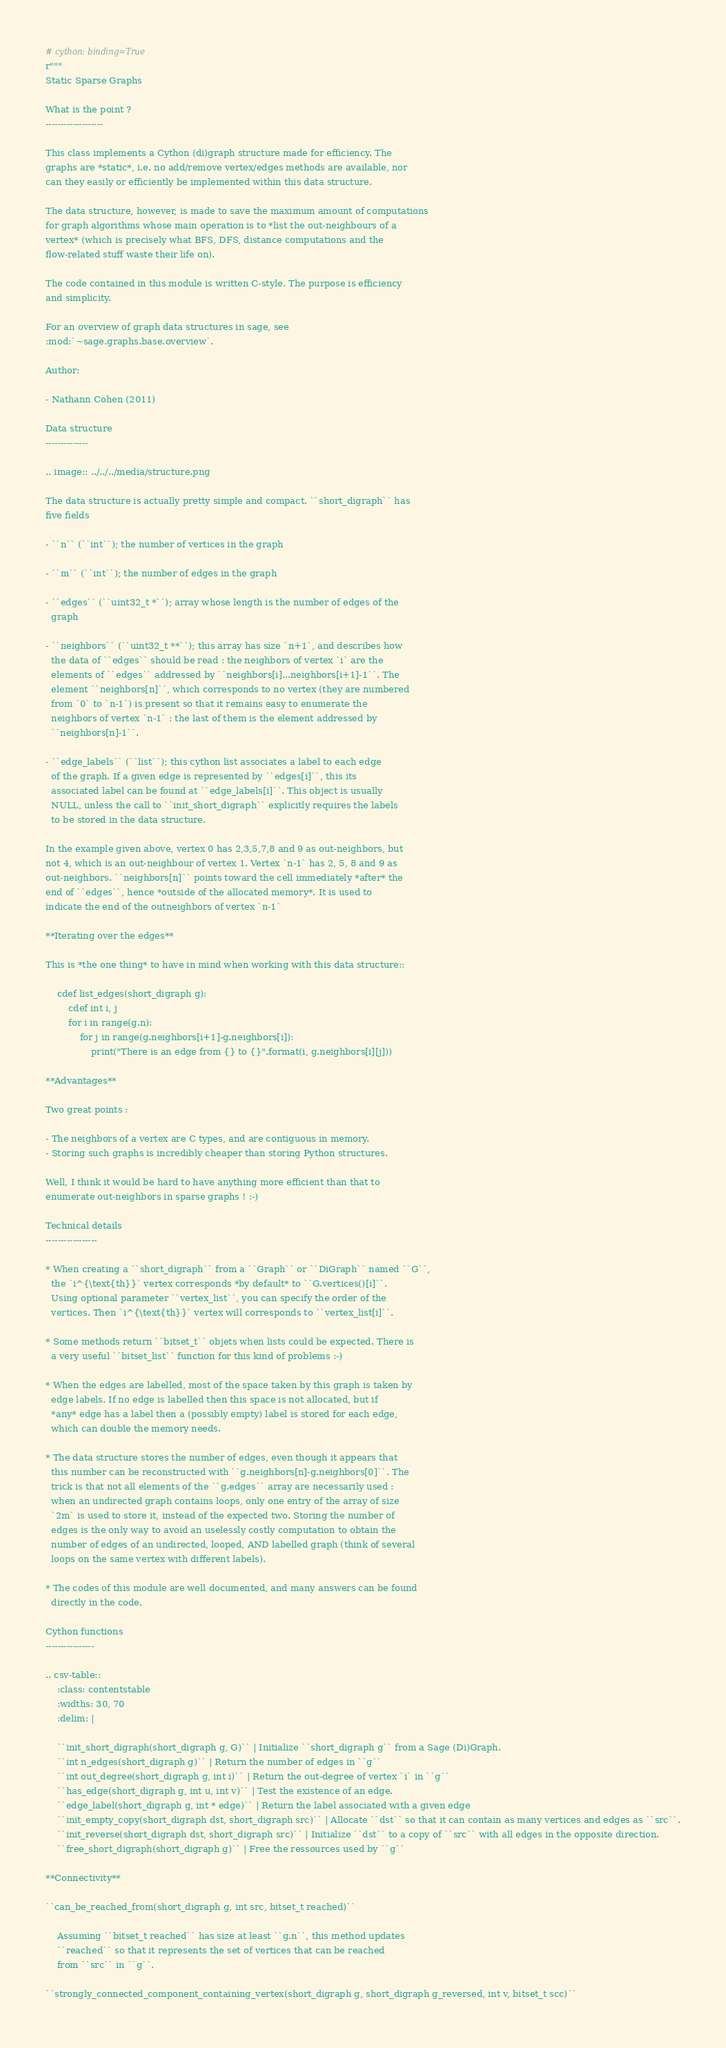Convert code to text. <code><loc_0><loc_0><loc_500><loc_500><_Cython_># cython: binding=True
r"""
Static Sparse Graphs

What is the point ?
-------------------

This class implements a Cython (di)graph structure made for efficiency. The
graphs are *static*, i.e. no add/remove vertex/edges methods are available, nor
can they easily or efficiently be implemented within this data structure.

The data structure, however, is made to save the maximum amount of computations
for graph algorithms whose main operation is to *list the out-neighbours of a
vertex* (which is precisely what BFS, DFS, distance computations and the
flow-related stuff waste their life on).

The code contained in this module is written C-style. The purpose is efficiency
and simplicity.

For an overview of graph data structures in sage, see
:mod:`~sage.graphs.base.overview`.

Author:

- Nathann Cohen (2011)

Data structure
--------------

.. image:: ../../../media/structure.png

The data structure is actually pretty simple and compact. ``short_digraph`` has
five fields

- ``n`` (``int``); the number of vertices in the graph

- ``m`` (``int``); the number of edges in the graph

- ``edges`` (``uint32_t *``); array whose length is the number of edges of the
  graph

- ``neighbors`` (``uint32_t **``); this array has size `n+1`, and describes how
  the data of ``edges`` should be read : the neighbors of vertex `i` are the
  elements of ``edges`` addressed by ``neighbors[i]...neighbors[i+1]-1``. The
  element ``neighbors[n]``, which corresponds to no vertex (they are numbered
  from `0` to `n-1`) is present so that it remains easy to enumerate the
  neighbors of vertex `n-1` : the last of them is the element addressed by
  ``neighbors[n]-1``.

- ``edge_labels`` (``list``); this cython list associates a label to each edge
  of the graph. If a given edge is represented by ``edges[i]``, this its
  associated label can be found at ``edge_labels[i]``. This object is usually
  NULL, unless the call to ``init_short_digraph`` explicitly requires the labels
  to be stored in the data structure.

In the example given above, vertex 0 has 2,3,5,7,8 and 9 as out-neighbors, but
not 4, which is an out-neighbour of vertex 1. Vertex `n-1` has 2, 5, 8 and 9 as
out-neighbors. ``neighbors[n]`` points toward the cell immediately *after* the
end of ``edges``, hence *outside of the allocated memory*. It is used to
indicate the end of the outneighbors of vertex `n-1`

**Iterating over the edges**

This is *the one thing* to have in mind when working with this data structure::

    cdef list_edges(short_digraph g):
        cdef int i, j
        for i in range(g.n):
            for j in range(g.neighbors[i+1]-g.neighbors[i]):
                print("There is an edge from {} to {}".format(i, g.neighbors[i][j]))

**Advantages**

Two great points :

- The neighbors of a vertex are C types, and are contiguous in memory.
- Storing such graphs is incredibly cheaper than storing Python structures.

Well, I think it would be hard to have anything more efficient than that to
enumerate out-neighbors in sparse graphs ! :-)

Technical details
-----------------

* When creating a ``short_digraph`` from a ``Graph`` or ``DiGraph`` named ``G``,
  the `i^{\text{th}}` vertex corresponds *by default* to ``G.vertices()[i]``.
  Using optional parameter ``vertex_list``, you can specify the order of the
  vertices. Then `i^{\text{th}}` vertex will corresponds to ``vertex_list[i]``.

* Some methods return ``bitset_t`` objets when lists could be expected. There is
  a very useful ``bitset_list`` function for this kind of problems :-)

* When the edges are labelled, most of the space taken by this graph is taken by
  edge labels. If no edge is labelled then this space is not allocated, but if
  *any* edge has a label then a (possibly empty) label is stored for each edge,
  which can double the memory needs.

* The data structure stores the number of edges, even though it appears that
  this number can be reconstructed with ``g.neighbors[n]-g.neighbors[0]``. The
  trick is that not all elements of the ``g.edges`` array are necessarily used :
  when an undirected graph contains loops, only one entry of the array of size
  `2m` is used to store it, instead of the expected two. Storing the number of
  edges is the only way to avoid an uselessly costly computation to obtain the
  number of edges of an undirected, looped, AND labelled graph (think of several
  loops on the same vertex with different labels).

* The codes of this module are well documented, and many answers can be found
  directly in the code.

Cython functions
----------------

.. csv-table::
    :class: contentstable
    :widths: 30, 70
    :delim: |

    ``init_short_digraph(short_digraph g, G)`` | Initialize ``short_digraph g`` from a Sage (Di)Graph.
    ``int n_edges(short_digraph g)`` | Return the number of edges in ``g``
    ``int out_degree(short_digraph g, int i)`` | Return the out-degree of vertex `i` in ``g``
    ``has_edge(short_digraph g, int u, int v)`` | Test the existence of an edge.
    ``edge_label(short_digraph g, int * edge)`` | Return the label associated with a given edge
    ``init_empty_copy(short_digraph dst, short_digraph src)`` | Allocate ``dst`` so that it can contain as many vertices and edges as ``src``.
    ``init_reverse(short_digraph dst, short_digraph src)`` | Initialize ``dst`` to a copy of ``src`` with all edges in the opposite direction.
    ``free_short_digraph(short_digraph g)`` | Free the ressources used by ``g``

**Connectivity**

``can_be_reached_from(short_digraph g, int src, bitset_t reached)``

    Assuming ``bitset_t reached`` has size at least ``g.n``, this method updates
    ``reached`` so that it represents the set of vertices that can be reached
    from ``src`` in ``g``.

``strongly_connected_component_containing_vertex(short_digraph g, short_digraph g_reversed, int v, bitset_t scc)``
</code> 